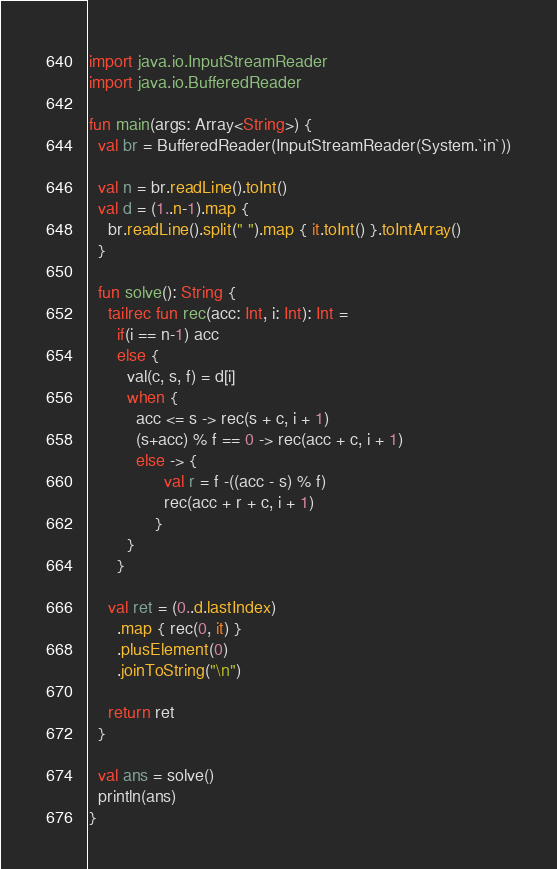Convert code to text. <code><loc_0><loc_0><loc_500><loc_500><_Kotlin_>import java.io.InputStreamReader
import java.io.BufferedReader

fun main(args: Array<String>) {
  val br = BufferedReader(InputStreamReader(System.`in`))

  val n = br.readLine().toInt()
  val d = (1..n-1).map {
    br.readLine().split(" ").map { it.toInt() }.toIntArray()
  }

  fun solve(): String {
    tailrec fun rec(acc: Int, i: Int): Int =
      if(i == n-1) acc
      else {
        val(c, s, f) = d[i]
        when {
          acc <= s -> rec(s + c, i + 1)
          (s+acc) % f == 0 -> rec(acc + c, i + 1)
          else -> {
                val r = f -((acc - s) % f)
                rec(acc + r + c, i + 1)
              }
        }
      }

    val ret = (0..d.lastIndex)
      .map { rec(0, it) }
      .plusElement(0)
      .joinToString("\n")

    return ret
  }

  val ans = solve()
  println(ans)
}</code> 